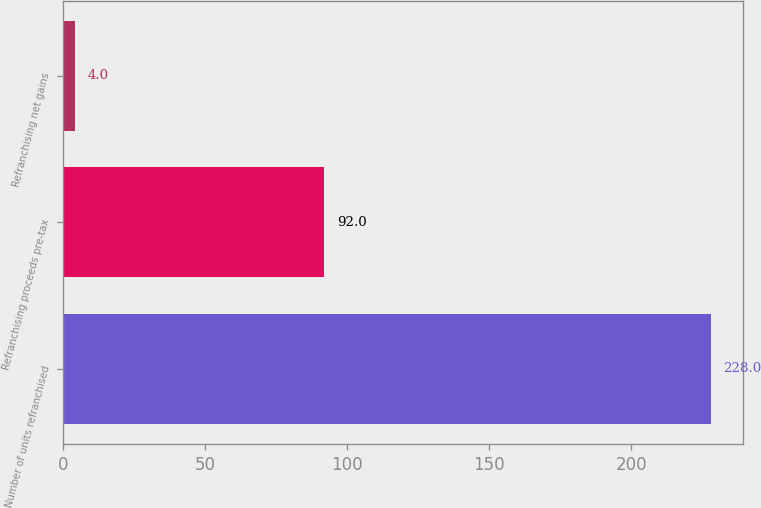<chart> <loc_0><loc_0><loc_500><loc_500><bar_chart><fcel>Number of units refranchised<fcel>Refranchising proceeds pre-tax<fcel>Refranchising net gains<nl><fcel>228<fcel>92<fcel>4<nl></chart> 